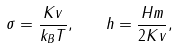<formula> <loc_0><loc_0><loc_500><loc_500>\sigma = \frac { K v } { k _ { B } T } , \quad h = \frac { H m } { 2 K v } ,</formula> 